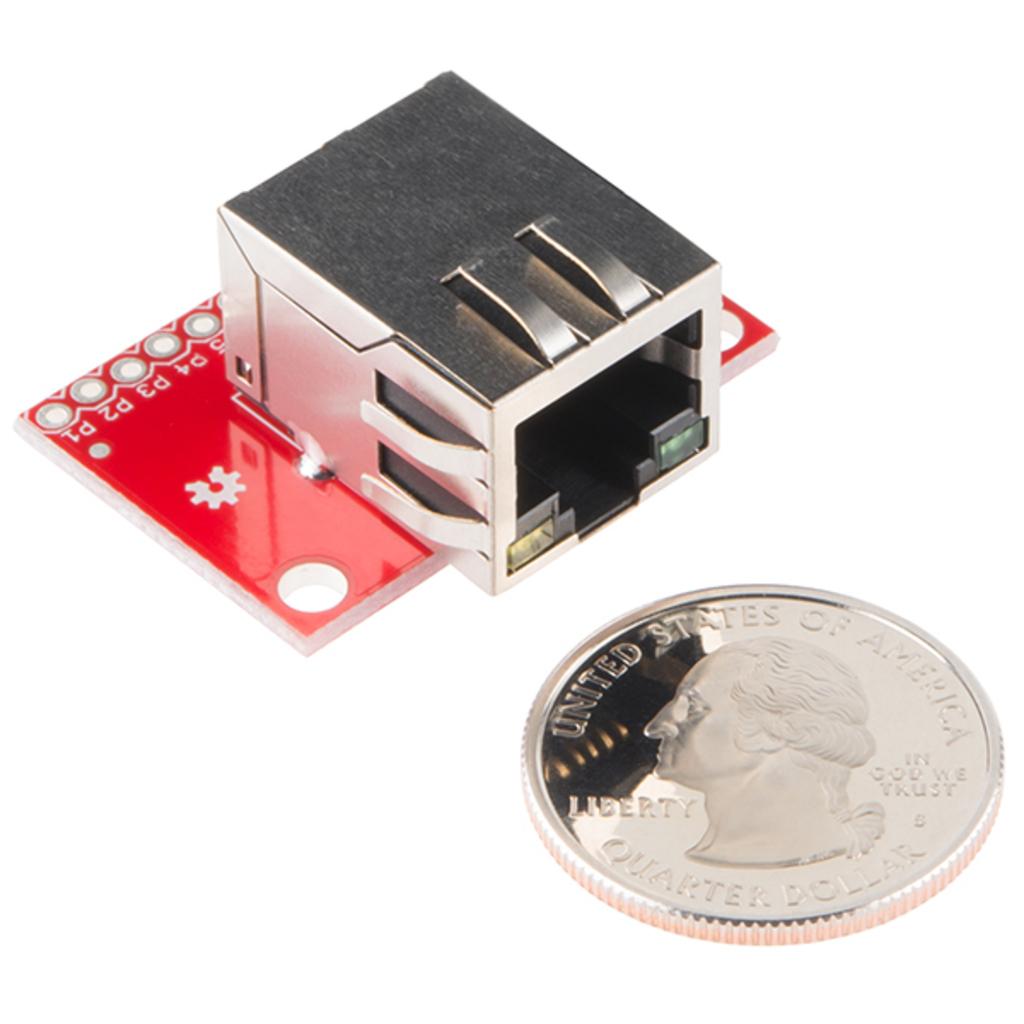Is this a quarter?
Your answer should be compact. Yes. How much is the coin worth?
Offer a terse response. Quarter dollar. 